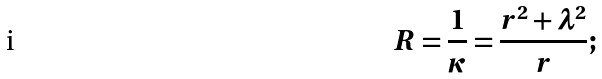<formula> <loc_0><loc_0><loc_500><loc_500>R = \frac { 1 } { \kappa } = \frac { r ^ { 2 } + \lambda ^ { 2 } } { r } ;</formula> 